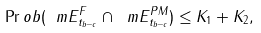Convert formula to latex. <formula><loc_0><loc_0><loc_500><loc_500>\Pr o b ( \ m E ^ { F } _ { t _ { b - c } } \cap \ m E ^ { P M } _ { t _ { b - c } } ) \leq K _ { 1 } + K _ { 2 } ,</formula> 